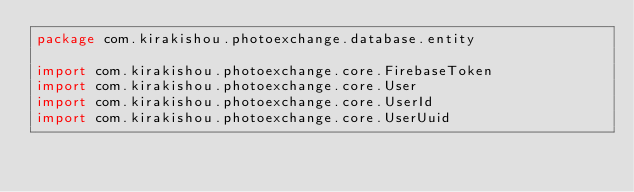Convert code to text. <code><loc_0><loc_0><loc_500><loc_500><_Kotlin_>package com.kirakishou.photoexchange.database.entity

import com.kirakishou.photoexchange.core.FirebaseToken
import com.kirakishou.photoexchange.core.User
import com.kirakishou.photoexchange.core.UserId
import com.kirakishou.photoexchange.core.UserUuid</code> 